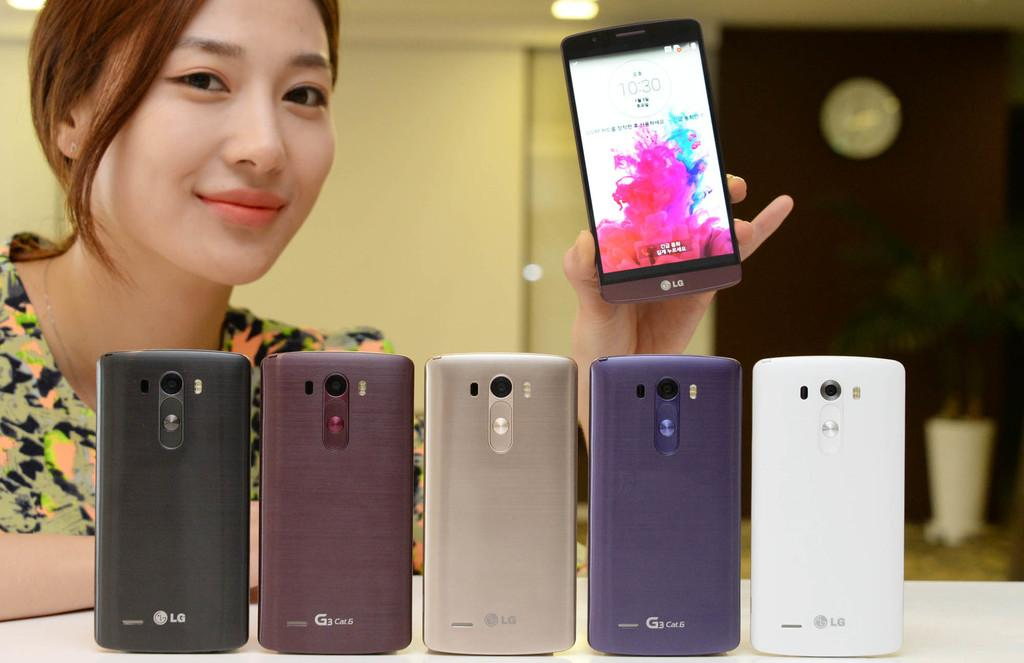<image>
Offer a succinct explanation of the picture presented. A girl holding up a phone showing the time of 10:30 